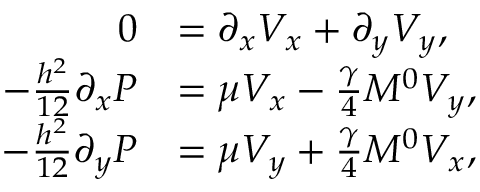Convert formula to latex. <formula><loc_0><loc_0><loc_500><loc_500>\begin{array} { r l } { 0 } & { = \partial _ { x } V _ { x } + \partial _ { y } V _ { y } , } \\ { - \frac { h ^ { 2 } } { 1 2 } \partial _ { x } P } & { = \mu V _ { x } - \frac { \gamma } { 4 } M ^ { 0 } V _ { y } , } \\ { - \frac { h ^ { 2 } } { 1 2 } \partial _ { y } P } & { = \mu V _ { y } + \frac { \gamma } { 4 } M ^ { 0 } V _ { x } , } \end{array}</formula> 